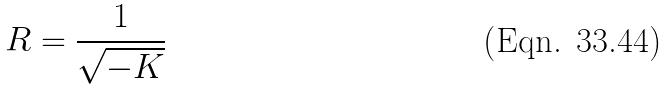Convert formula to latex. <formula><loc_0><loc_0><loc_500><loc_500>R = \frac { 1 } { \sqrt { - K } }</formula> 